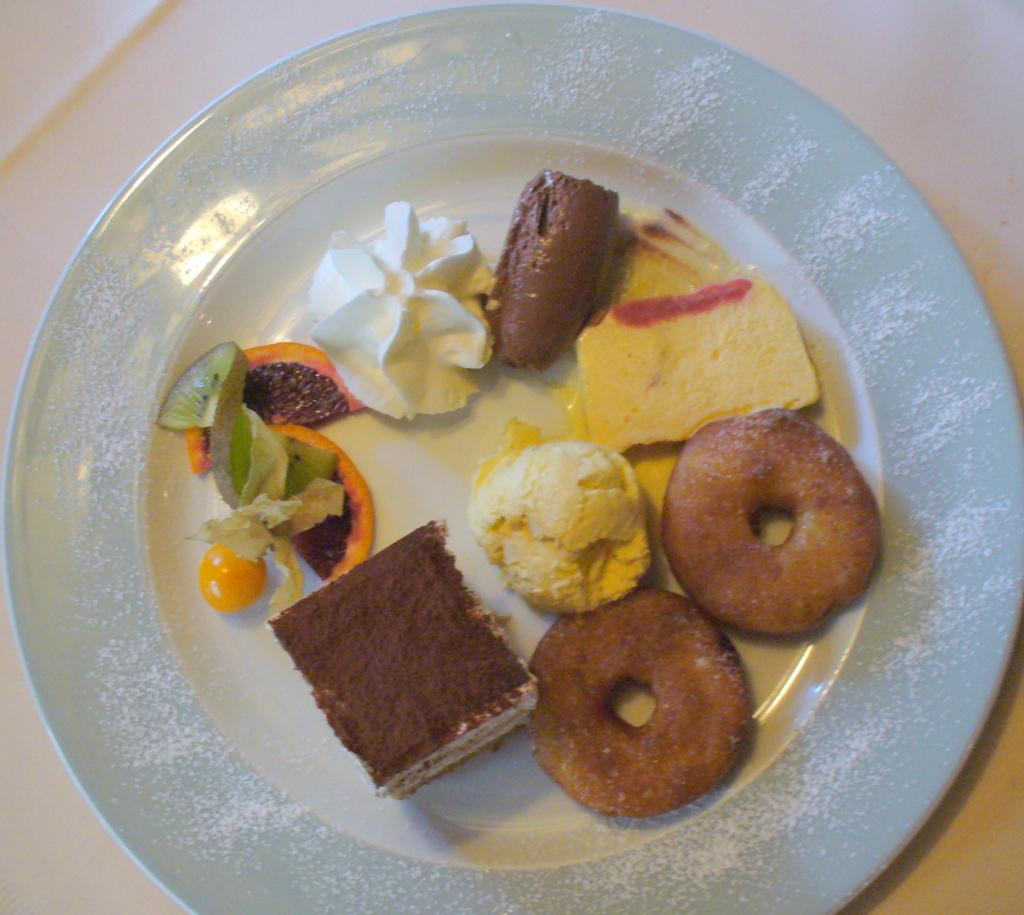What is on the plate in the image? There is food on a white color plate in the image. Can you describe the colors of the food on the plate? The food has various colors, including brown, white, green, red, and orange. What is the color of the surface the plate is on? The plate is on a white color surface. How many trees are visible in the image? There are no trees visible in the image; it only shows a plate with food on a white surface. 